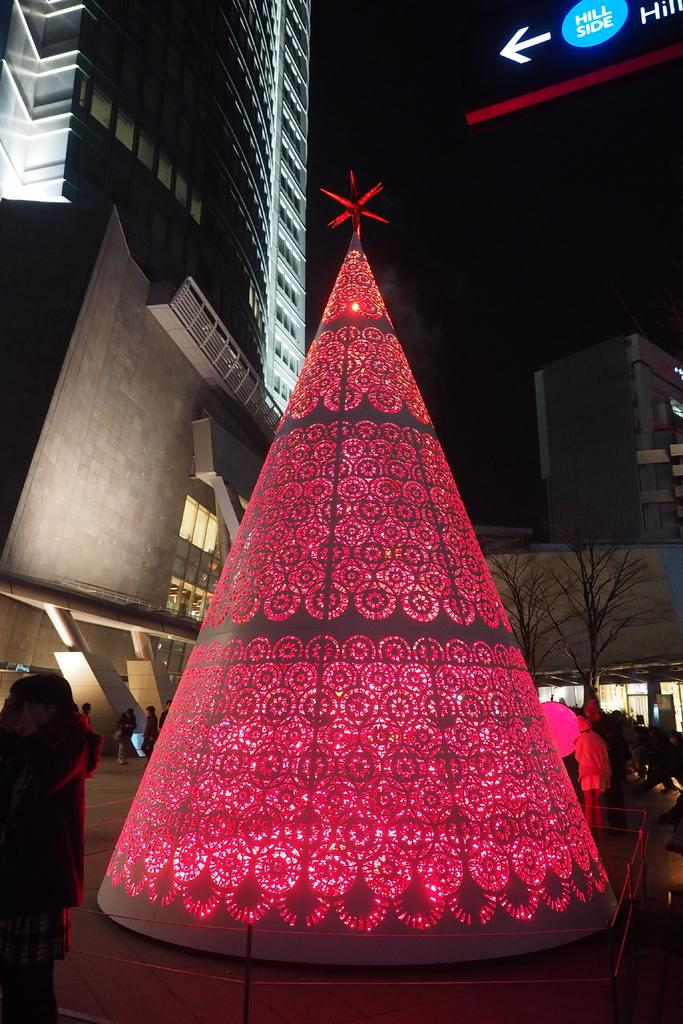What is the main subject of the image? There is an object in the image. What else can be seen in the image besides the object? There are people on the ground, buildings, and trees visible in the image. How would you describe the lighting in the image? The background of the image is dark. What type of amusement can be seen in the image? There is no amusement present in the image; it features an object, people, buildings, trees, and a dark background. What is being served for dinner in the image? There is no dinner or food present in the image. 